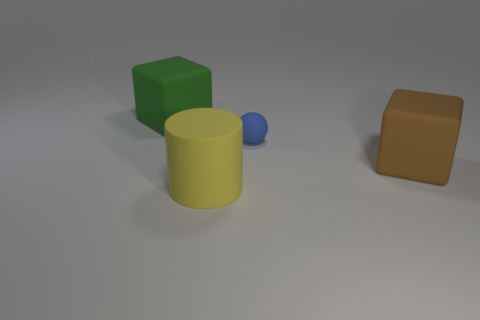Add 3 small cyan rubber things. How many objects exist? 7 Subtract all balls. How many objects are left? 3 Subtract all blue matte balls. Subtract all cyan rubber things. How many objects are left? 3 Add 3 small spheres. How many small spheres are left? 4 Add 3 cyan rubber objects. How many cyan rubber objects exist? 3 Subtract 1 brown blocks. How many objects are left? 3 